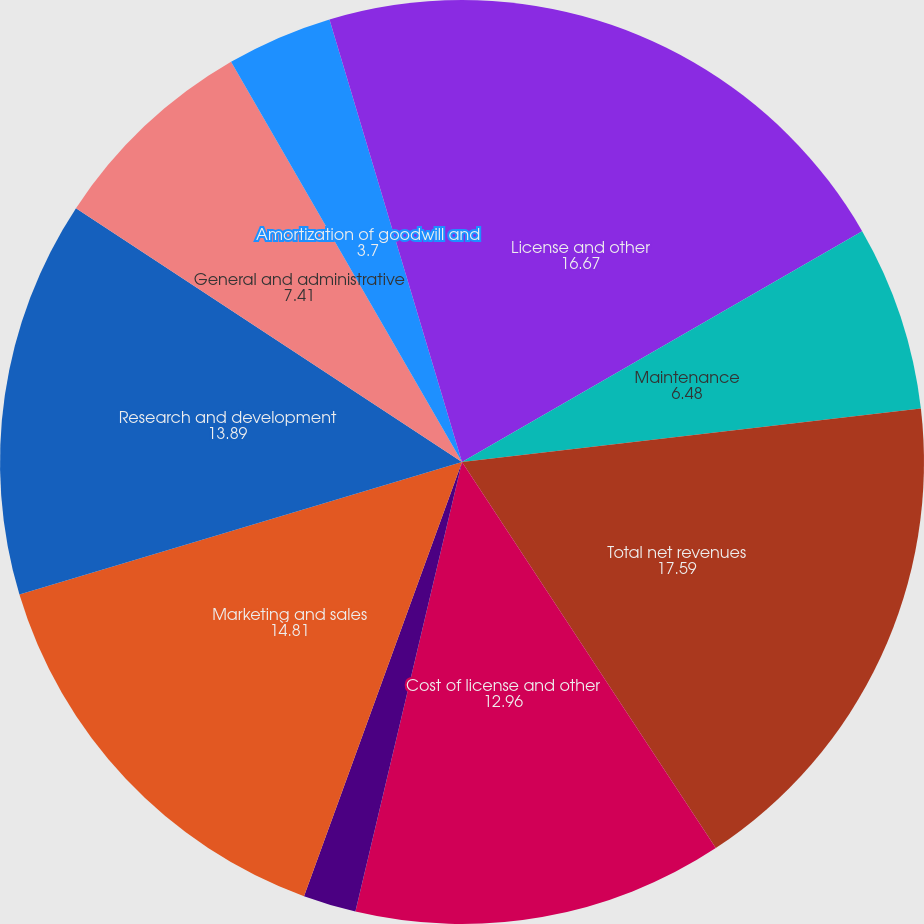Convert chart to OTSL. <chart><loc_0><loc_0><loc_500><loc_500><pie_chart><fcel>License and other<fcel>Maintenance<fcel>Total net revenues<fcel>Cost of license and other<fcel>Cost of maintenance revenues<fcel>Marketing and sales<fcel>Research and development<fcel>General and administrative<fcel>Amortization of goodwill and<fcel>Restructuring and other<nl><fcel>16.67%<fcel>6.48%<fcel>17.59%<fcel>12.96%<fcel>1.85%<fcel>14.81%<fcel>13.89%<fcel>7.41%<fcel>3.7%<fcel>4.63%<nl></chart> 